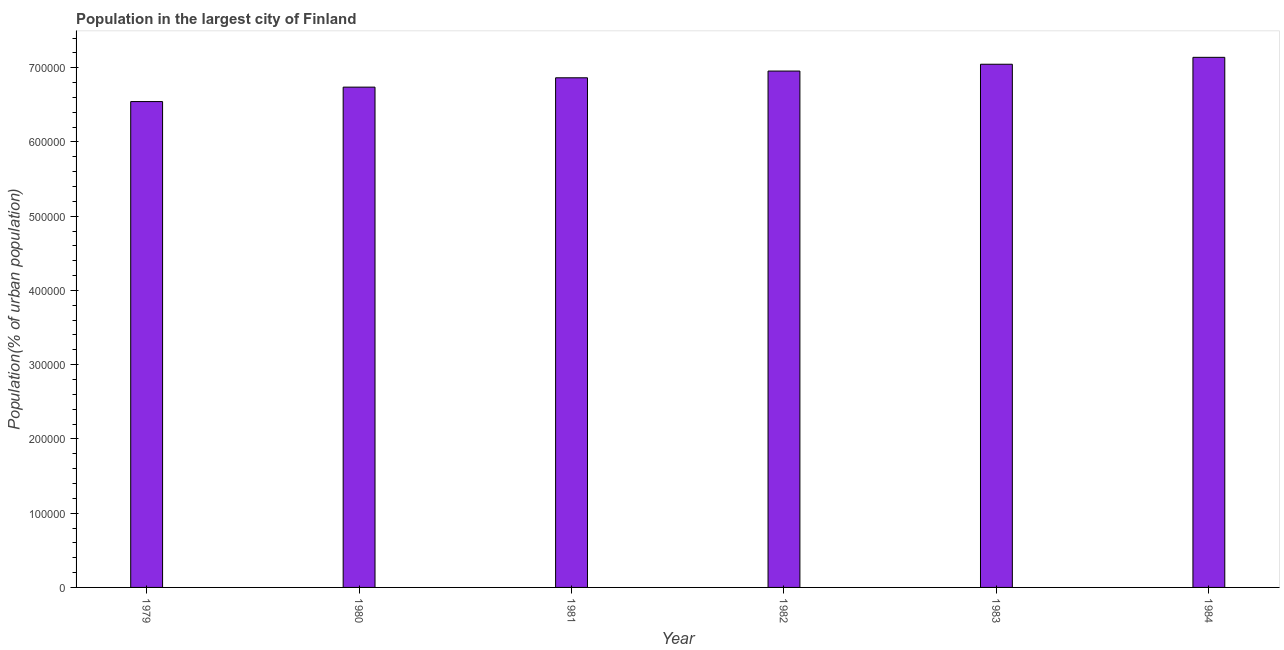Does the graph contain any zero values?
Ensure brevity in your answer.  No. Does the graph contain grids?
Your answer should be compact. No. What is the title of the graph?
Offer a very short reply. Population in the largest city of Finland. What is the label or title of the X-axis?
Provide a succinct answer. Year. What is the label or title of the Y-axis?
Provide a short and direct response. Population(% of urban population). What is the population in largest city in 1984?
Offer a very short reply. 7.14e+05. Across all years, what is the maximum population in largest city?
Your answer should be very brief. 7.14e+05. Across all years, what is the minimum population in largest city?
Offer a terse response. 6.54e+05. In which year was the population in largest city maximum?
Provide a succinct answer. 1984. In which year was the population in largest city minimum?
Provide a succinct answer. 1979. What is the sum of the population in largest city?
Offer a terse response. 4.13e+06. What is the difference between the population in largest city in 1979 and 1982?
Your response must be concise. -4.11e+04. What is the average population in largest city per year?
Your answer should be very brief. 6.88e+05. What is the median population in largest city?
Make the answer very short. 6.91e+05. In how many years, is the population in largest city greater than 420000 %?
Your response must be concise. 6. What is the difference between the highest and the second highest population in largest city?
Make the answer very short. 9313. What is the difference between the highest and the lowest population in largest city?
Your answer should be compact. 5.96e+04. In how many years, is the population in largest city greater than the average population in largest city taken over all years?
Your response must be concise. 3. How many bars are there?
Offer a terse response. 6. Are all the bars in the graph horizontal?
Your answer should be compact. No. How many years are there in the graph?
Provide a short and direct response. 6. What is the difference between two consecutive major ticks on the Y-axis?
Offer a very short reply. 1.00e+05. Are the values on the major ticks of Y-axis written in scientific E-notation?
Provide a short and direct response. No. What is the Population(% of urban population) of 1979?
Offer a terse response. 6.54e+05. What is the Population(% of urban population) of 1980?
Provide a succinct answer. 6.74e+05. What is the Population(% of urban population) of 1981?
Keep it short and to the point. 6.86e+05. What is the Population(% of urban population) of 1982?
Offer a very short reply. 6.96e+05. What is the Population(% of urban population) in 1983?
Provide a short and direct response. 7.05e+05. What is the Population(% of urban population) in 1984?
Offer a terse response. 7.14e+05. What is the difference between the Population(% of urban population) in 1979 and 1980?
Give a very brief answer. -1.95e+04. What is the difference between the Population(% of urban population) in 1979 and 1981?
Keep it short and to the point. -3.20e+04. What is the difference between the Population(% of urban population) in 1979 and 1982?
Ensure brevity in your answer.  -4.11e+04. What is the difference between the Population(% of urban population) in 1979 and 1983?
Offer a terse response. -5.03e+04. What is the difference between the Population(% of urban population) in 1979 and 1984?
Keep it short and to the point. -5.96e+04. What is the difference between the Population(% of urban population) in 1980 and 1981?
Give a very brief answer. -1.26e+04. What is the difference between the Population(% of urban population) in 1980 and 1982?
Your response must be concise. -2.17e+04. What is the difference between the Population(% of urban population) in 1980 and 1983?
Make the answer very short. -3.08e+04. What is the difference between the Population(% of urban population) in 1980 and 1984?
Make the answer very short. -4.01e+04. What is the difference between the Population(% of urban population) in 1981 and 1982?
Offer a terse response. -9059. What is the difference between the Population(% of urban population) in 1981 and 1983?
Your response must be concise. -1.82e+04. What is the difference between the Population(% of urban population) in 1981 and 1984?
Give a very brief answer. -2.76e+04. What is the difference between the Population(% of urban population) in 1982 and 1983?
Ensure brevity in your answer.  -9179. What is the difference between the Population(% of urban population) in 1982 and 1984?
Offer a very short reply. -1.85e+04. What is the difference between the Population(% of urban population) in 1983 and 1984?
Give a very brief answer. -9313. What is the ratio of the Population(% of urban population) in 1979 to that in 1981?
Your answer should be compact. 0.95. What is the ratio of the Population(% of urban population) in 1979 to that in 1982?
Make the answer very short. 0.94. What is the ratio of the Population(% of urban population) in 1979 to that in 1983?
Give a very brief answer. 0.93. What is the ratio of the Population(% of urban population) in 1979 to that in 1984?
Offer a terse response. 0.92. What is the ratio of the Population(% of urban population) in 1980 to that in 1981?
Offer a terse response. 0.98. What is the ratio of the Population(% of urban population) in 1980 to that in 1983?
Ensure brevity in your answer.  0.96. What is the ratio of the Population(% of urban population) in 1980 to that in 1984?
Keep it short and to the point. 0.94. What is the ratio of the Population(% of urban population) in 1981 to that in 1982?
Your answer should be compact. 0.99. What is the ratio of the Population(% of urban population) in 1981 to that in 1983?
Your answer should be very brief. 0.97. What is the ratio of the Population(% of urban population) in 1981 to that in 1984?
Provide a short and direct response. 0.96. What is the ratio of the Population(% of urban population) in 1982 to that in 1984?
Offer a terse response. 0.97. What is the ratio of the Population(% of urban population) in 1983 to that in 1984?
Offer a terse response. 0.99. 